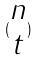<formula> <loc_0><loc_0><loc_500><loc_500>( \begin{matrix} n \\ t \end{matrix} )</formula> 